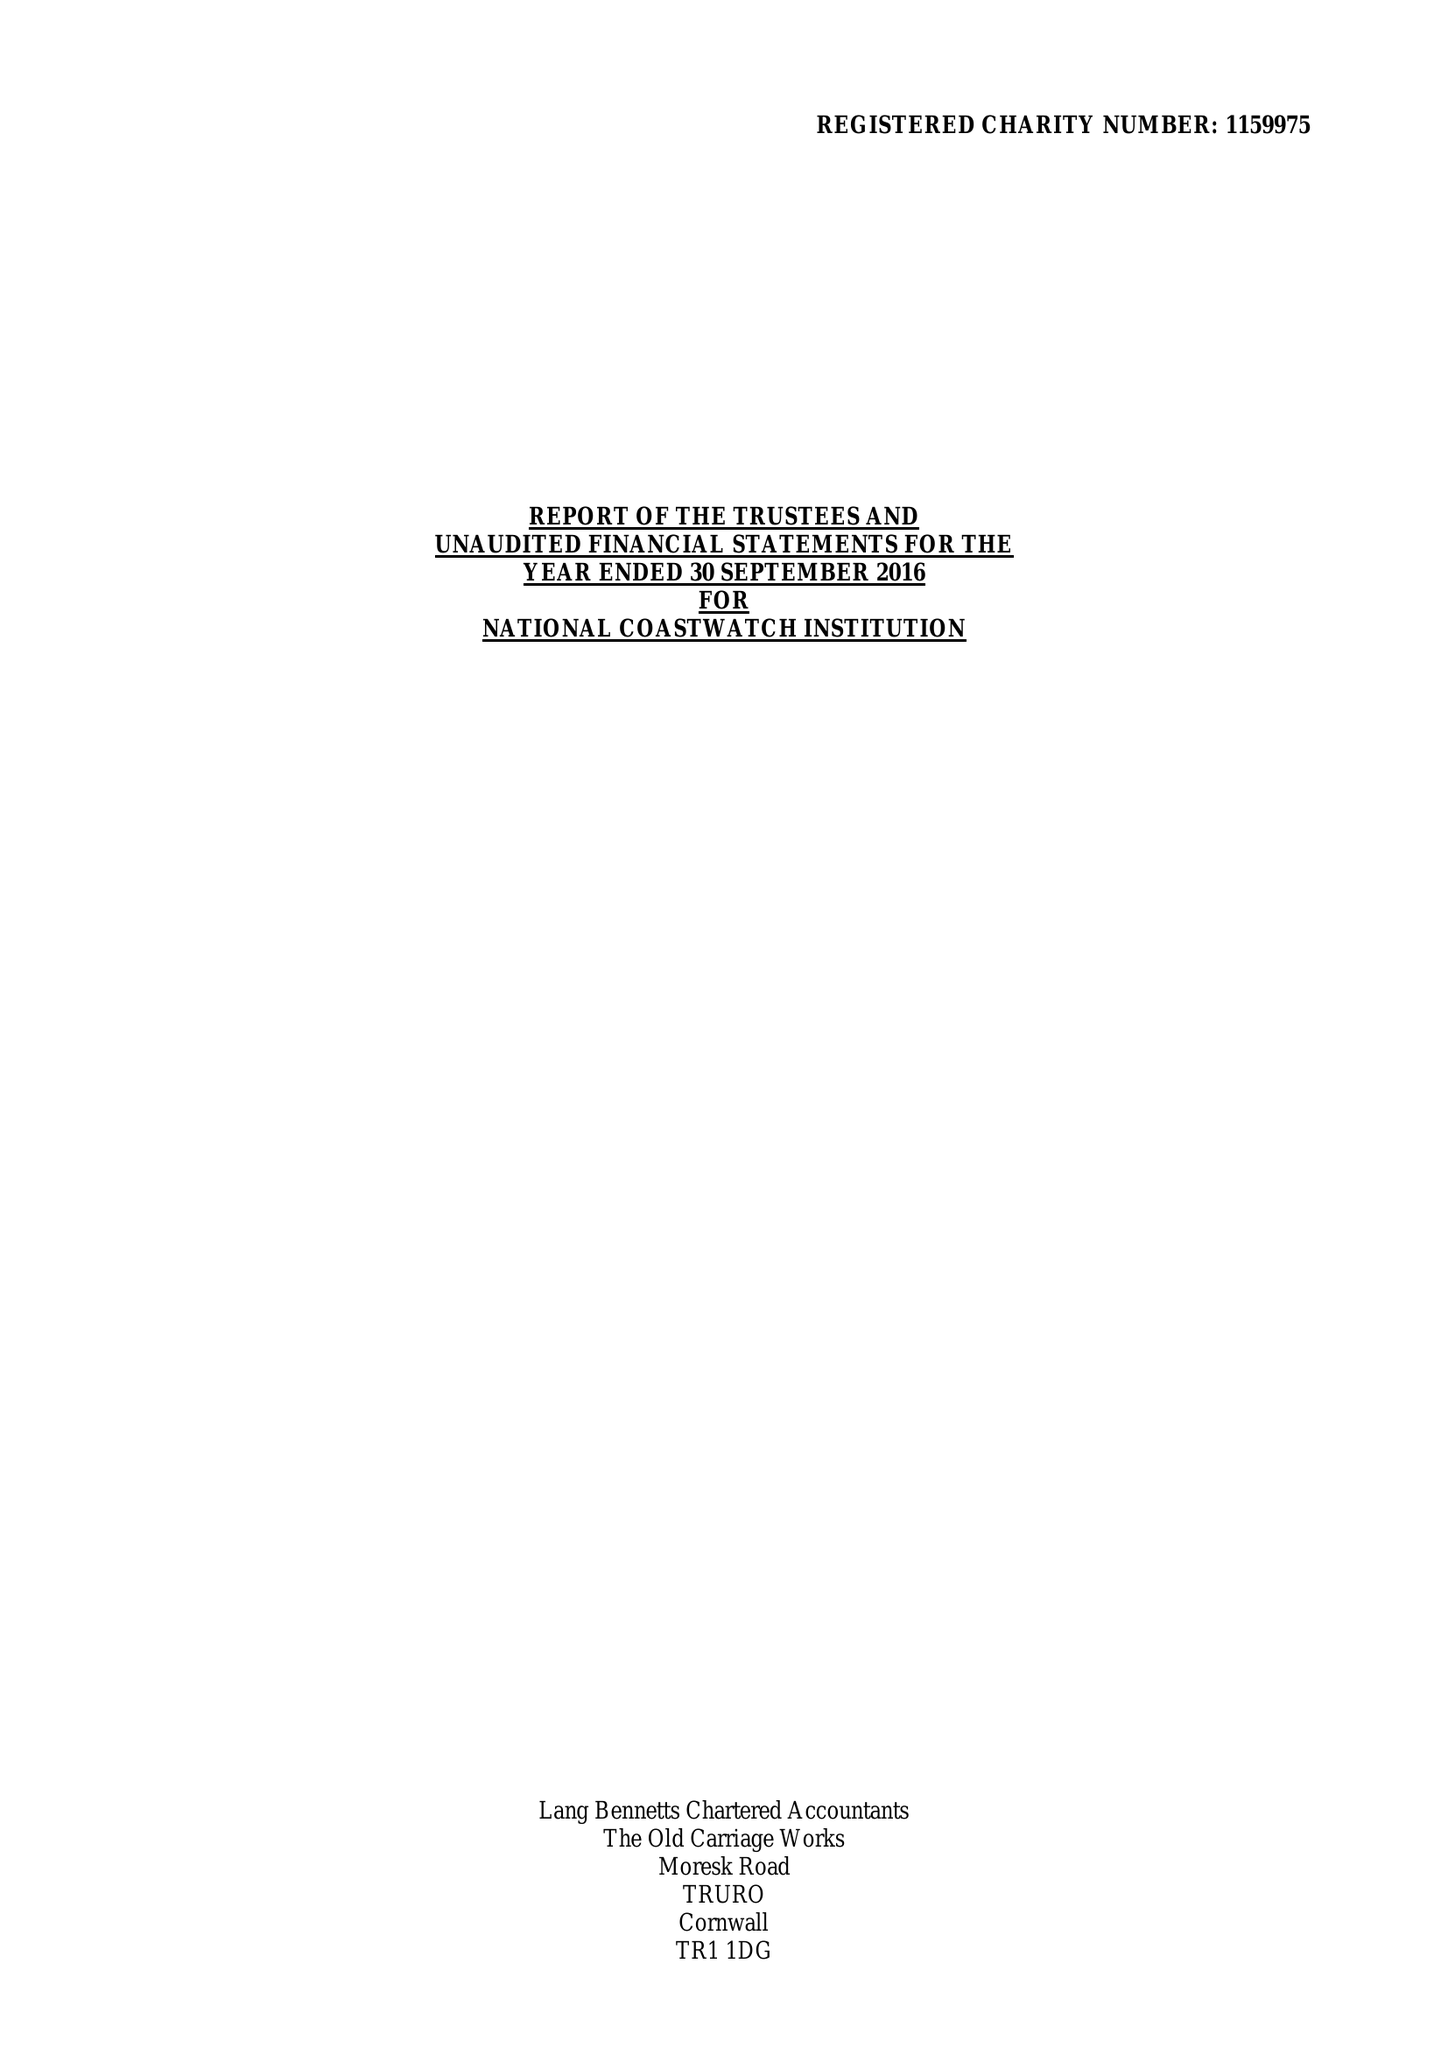What is the value for the charity_name?
Answer the question using a single word or phrase. National Coastwatch Institution 